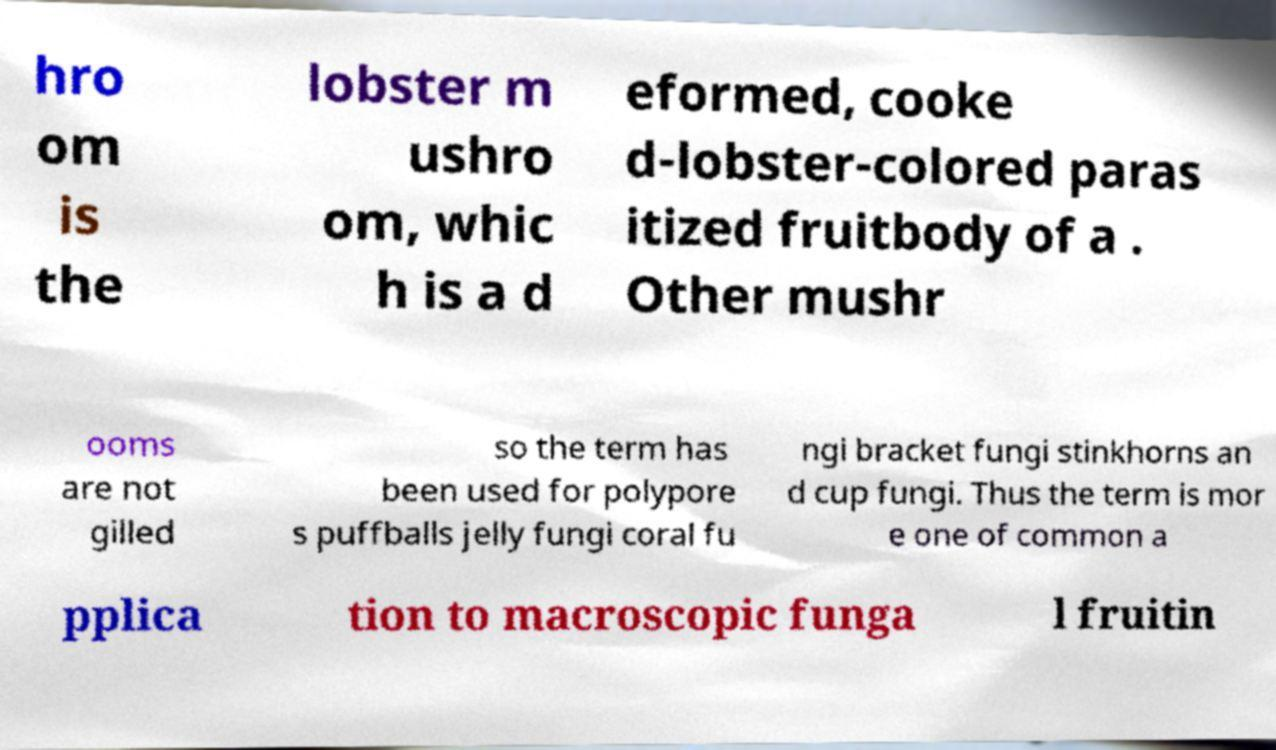Please read and relay the text visible in this image. What does it say? hro om is the lobster m ushro om, whic h is a d eformed, cooke d-lobster-colored paras itized fruitbody of a . Other mushr ooms are not gilled so the term has been used for polypore s puffballs jelly fungi coral fu ngi bracket fungi stinkhorns an d cup fungi. Thus the term is mor e one of common a pplica tion to macroscopic funga l fruitin 